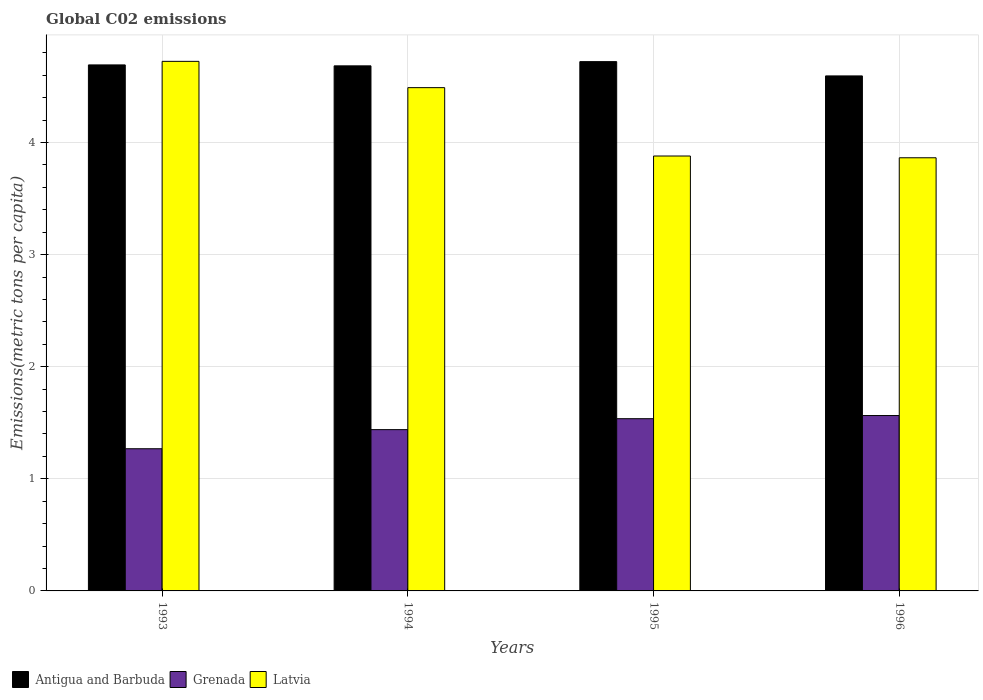How many groups of bars are there?
Your answer should be very brief. 4. Are the number of bars per tick equal to the number of legend labels?
Offer a very short reply. Yes. Are the number of bars on each tick of the X-axis equal?
Offer a terse response. Yes. What is the label of the 4th group of bars from the left?
Your answer should be very brief. 1996. In how many cases, is the number of bars for a given year not equal to the number of legend labels?
Offer a very short reply. 0. What is the amount of CO2 emitted in in Antigua and Barbuda in 1993?
Offer a very short reply. 4.69. Across all years, what is the maximum amount of CO2 emitted in in Antigua and Barbuda?
Ensure brevity in your answer.  4.72. Across all years, what is the minimum amount of CO2 emitted in in Grenada?
Ensure brevity in your answer.  1.27. What is the total amount of CO2 emitted in in Antigua and Barbuda in the graph?
Provide a short and direct response. 18.69. What is the difference between the amount of CO2 emitted in in Latvia in 1993 and that in 1994?
Offer a terse response. 0.23. What is the difference between the amount of CO2 emitted in in Antigua and Barbuda in 1993 and the amount of CO2 emitted in in Latvia in 1996?
Provide a short and direct response. 0.83. What is the average amount of CO2 emitted in in Grenada per year?
Provide a short and direct response. 1.45. In the year 1994, what is the difference between the amount of CO2 emitted in in Latvia and amount of CO2 emitted in in Antigua and Barbuda?
Keep it short and to the point. -0.19. What is the ratio of the amount of CO2 emitted in in Latvia in 1994 to that in 1995?
Offer a very short reply. 1.16. Is the difference between the amount of CO2 emitted in in Latvia in 1995 and 1996 greater than the difference between the amount of CO2 emitted in in Antigua and Barbuda in 1995 and 1996?
Your response must be concise. No. What is the difference between the highest and the second highest amount of CO2 emitted in in Antigua and Barbuda?
Offer a very short reply. 0.03. What is the difference between the highest and the lowest amount of CO2 emitted in in Latvia?
Give a very brief answer. 0.86. In how many years, is the amount of CO2 emitted in in Latvia greater than the average amount of CO2 emitted in in Latvia taken over all years?
Offer a terse response. 2. What does the 1st bar from the left in 1994 represents?
Offer a terse response. Antigua and Barbuda. What does the 3rd bar from the right in 1993 represents?
Offer a terse response. Antigua and Barbuda. How many bars are there?
Offer a terse response. 12. Are all the bars in the graph horizontal?
Offer a very short reply. No. How many years are there in the graph?
Offer a very short reply. 4. Does the graph contain any zero values?
Your answer should be compact. No. Where does the legend appear in the graph?
Provide a succinct answer. Bottom left. What is the title of the graph?
Your answer should be very brief. Global C02 emissions. What is the label or title of the Y-axis?
Your response must be concise. Emissions(metric tons per capita). What is the Emissions(metric tons per capita) of Antigua and Barbuda in 1993?
Your answer should be very brief. 4.69. What is the Emissions(metric tons per capita) of Grenada in 1993?
Your response must be concise. 1.27. What is the Emissions(metric tons per capita) of Latvia in 1993?
Make the answer very short. 4.72. What is the Emissions(metric tons per capita) in Antigua and Barbuda in 1994?
Offer a very short reply. 4.68. What is the Emissions(metric tons per capita) in Grenada in 1994?
Give a very brief answer. 1.44. What is the Emissions(metric tons per capita) in Latvia in 1994?
Provide a short and direct response. 4.49. What is the Emissions(metric tons per capita) in Antigua and Barbuda in 1995?
Keep it short and to the point. 4.72. What is the Emissions(metric tons per capita) in Grenada in 1995?
Provide a short and direct response. 1.54. What is the Emissions(metric tons per capita) of Latvia in 1995?
Your response must be concise. 3.88. What is the Emissions(metric tons per capita) of Antigua and Barbuda in 1996?
Offer a very short reply. 4.59. What is the Emissions(metric tons per capita) of Grenada in 1996?
Your answer should be very brief. 1.56. What is the Emissions(metric tons per capita) of Latvia in 1996?
Provide a succinct answer. 3.86. Across all years, what is the maximum Emissions(metric tons per capita) of Antigua and Barbuda?
Your answer should be very brief. 4.72. Across all years, what is the maximum Emissions(metric tons per capita) of Grenada?
Offer a very short reply. 1.56. Across all years, what is the maximum Emissions(metric tons per capita) in Latvia?
Offer a terse response. 4.72. Across all years, what is the minimum Emissions(metric tons per capita) in Antigua and Barbuda?
Give a very brief answer. 4.59. Across all years, what is the minimum Emissions(metric tons per capita) of Grenada?
Your answer should be compact. 1.27. Across all years, what is the minimum Emissions(metric tons per capita) of Latvia?
Make the answer very short. 3.86. What is the total Emissions(metric tons per capita) of Antigua and Barbuda in the graph?
Provide a succinct answer. 18.69. What is the total Emissions(metric tons per capita) of Grenada in the graph?
Your response must be concise. 5.81. What is the total Emissions(metric tons per capita) of Latvia in the graph?
Provide a succinct answer. 16.96. What is the difference between the Emissions(metric tons per capita) in Antigua and Barbuda in 1993 and that in 1994?
Make the answer very short. 0.01. What is the difference between the Emissions(metric tons per capita) of Grenada in 1993 and that in 1994?
Your answer should be very brief. -0.17. What is the difference between the Emissions(metric tons per capita) of Latvia in 1993 and that in 1994?
Your answer should be compact. 0.23. What is the difference between the Emissions(metric tons per capita) in Antigua and Barbuda in 1993 and that in 1995?
Your answer should be very brief. -0.03. What is the difference between the Emissions(metric tons per capita) in Grenada in 1993 and that in 1995?
Ensure brevity in your answer.  -0.27. What is the difference between the Emissions(metric tons per capita) of Latvia in 1993 and that in 1995?
Offer a very short reply. 0.84. What is the difference between the Emissions(metric tons per capita) of Antigua and Barbuda in 1993 and that in 1996?
Offer a terse response. 0.1. What is the difference between the Emissions(metric tons per capita) in Grenada in 1993 and that in 1996?
Give a very brief answer. -0.3. What is the difference between the Emissions(metric tons per capita) of Latvia in 1993 and that in 1996?
Give a very brief answer. 0.86. What is the difference between the Emissions(metric tons per capita) in Antigua and Barbuda in 1994 and that in 1995?
Ensure brevity in your answer.  -0.04. What is the difference between the Emissions(metric tons per capita) of Grenada in 1994 and that in 1995?
Provide a succinct answer. -0.1. What is the difference between the Emissions(metric tons per capita) in Latvia in 1994 and that in 1995?
Ensure brevity in your answer.  0.61. What is the difference between the Emissions(metric tons per capita) in Antigua and Barbuda in 1994 and that in 1996?
Offer a terse response. 0.09. What is the difference between the Emissions(metric tons per capita) of Grenada in 1994 and that in 1996?
Give a very brief answer. -0.13. What is the difference between the Emissions(metric tons per capita) of Latvia in 1994 and that in 1996?
Provide a succinct answer. 0.63. What is the difference between the Emissions(metric tons per capita) in Antigua and Barbuda in 1995 and that in 1996?
Your answer should be compact. 0.13. What is the difference between the Emissions(metric tons per capita) of Grenada in 1995 and that in 1996?
Offer a terse response. -0.03. What is the difference between the Emissions(metric tons per capita) of Latvia in 1995 and that in 1996?
Offer a terse response. 0.02. What is the difference between the Emissions(metric tons per capita) in Antigua and Barbuda in 1993 and the Emissions(metric tons per capita) in Grenada in 1994?
Offer a very short reply. 3.25. What is the difference between the Emissions(metric tons per capita) in Antigua and Barbuda in 1993 and the Emissions(metric tons per capita) in Latvia in 1994?
Provide a short and direct response. 0.2. What is the difference between the Emissions(metric tons per capita) of Grenada in 1993 and the Emissions(metric tons per capita) of Latvia in 1994?
Keep it short and to the point. -3.22. What is the difference between the Emissions(metric tons per capita) of Antigua and Barbuda in 1993 and the Emissions(metric tons per capita) of Grenada in 1995?
Offer a terse response. 3.16. What is the difference between the Emissions(metric tons per capita) in Antigua and Barbuda in 1993 and the Emissions(metric tons per capita) in Latvia in 1995?
Offer a very short reply. 0.81. What is the difference between the Emissions(metric tons per capita) of Grenada in 1993 and the Emissions(metric tons per capita) of Latvia in 1995?
Your response must be concise. -2.61. What is the difference between the Emissions(metric tons per capita) in Antigua and Barbuda in 1993 and the Emissions(metric tons per capita) in Grenada in 1996?
Offer a very short reply. 3.13. What is the difference between the Emissions(metric tons per capita) in Antigua and Barbuda in 1993 and the Emissions(metric tons per capita) in Latvia in 1996?
Your answer should be very brief. 0.83. What is the difference between the Emissions(metric tons per capita) of Grenada in 1993 and the Emissions(metric tons per capita) of Latvia in 1996?
Your answer should be very brief. -2.6. What is the difference between the Emissions(metric tons per capita) of Antigua and Barbuda in 1994 and the Emissions(metric tons per capita) of Grenada in 1995?
Your answer should be compact. 3.15. What is the difference between the Emissions(metric tons per capita) in Antigua and Barbuda in 1994 and the Emissions(metric tons per capita) in Latvia in 1995?
Provide a succinct answer. 0.8. What is the difference between the Emissions(metric tons per capita) of Grenada in 1994 and the Emissions(metric tons per capita) of Latvia in 1995?
Keep it short and to the point. -2.44. What is the difference between the Emissions(metric tons per capita) in Antigua and Barbuda in 1994 and the Emissions(metric tons per capita) in Grenada in 1996?
Offer a very short reply. 3.12. What is the difference between the Emissions(metric tons per capita) of Antigua and Barbuda in 1994 and the Emissions(metric tons per capita) of Latvia in 1996?
Give a very brief answer. 0.82. What is the difference between the Emissions(metric tons per capita) of Grenada in 1994 and the Emissions(metric tons per capita) of Latvia in 1996?
Your answer should be very brief. -2.42. What is the difference between the Emissions(metric tons per capita) in Antigua and Barbuda in 1995 and the Emissions(metric tons per capita) in Grenada in 1996?
Offer a terse response. 3.16. What is the difference between the Emissions(metric tons per capita) of Antigua and Barbuda in 1995 and the Emissions(metric tons per capita) of Latvia in 1996?
Your response must be concise. 0.86. What is the difference between the Emissions(metric tons per capita) of Grenada in 1995 and the Emissions(metric tons per capita) of Latvia in 1996?
Provide a succinct answer. -2.33. What is the average Emissions(metric tons per capita) in Antigua and Barbuda per year?
Your answer should be very brief. 4.67. What is the average Emissions(metric tons per capita) in Grenada per year?
Make the answer very short. 1.45. What is the average Emissions(metric tons per capita) of Latvia per year?
Give a very brief answer. 4.24. In the year 1993, what is the difference between the Emissions(metric tons per capita) in Antigua and Barbuda and Emissions(metric tons per capita) in Grenada?
Give a very brief answer. 3.42. In the year 1993, what is the difference between the Emissions(metric tons per capita) in Antigua and Barbuda and Emissions(metric tons per capita) in Latvia?
Your response must be concise. -0.03. In the year 1993, what is the difference between the Emissions(metric tons per capita) in Grenada and Emissions(metric tons per capita) in Latvia?
Ensure brevity in your answer.  -3.46. In the year 1994, what is the difference between the Emissions(metric tons per capita) in Antigua and Barbuda and Emissions(metric tons per capita) in Grenada?
Ensure brevity in your answer.  3.24. In the year 1994, what is the difference between the Emissions(metric tons per capita) in Antigua and Barbuda and Emissions(metric tons per capita) in Latvia?
Offer a terse response. 0.19. In the year 1994, what is the difference between the Emissions(metric tons per capita) of Grenada and Emissions(metric tons per capita) of Latvia?
Your response must be concise. -3.05. In the year 1995, what is the difference between the Emissions(metric tons per capita) in Antigua and Barbuda and Emissions(metric tons per capita) in Grenada?
Your answer should be very brief. 3.19. In the year 1995, what is the difference between the Emissions(metric tons per capita) in Antigua and Barbuda and Emissions(metric tons per capita) in Latvia?
Make the answer very short. 0.84. In the year 1995, what is the difference between the Emissions(metric tons per capita) in Grenada and Emissions(metric tons per capita) in Latvia?
Keep it short and to the point. -2.34. In the year 1996, what is the difference between the Emissions(metric tons per capita) in Antigua and Barbuda and Emissions(metric tons per capita) in Grenada?
Provide a succinct answer. 3.03. In the year 1996, what is the difference between the Emissions(metric tons per capita) in Antigua and Barbuda and Emissions(metric tons per capita) in Latvia?
Your answer should be very brief. 0.73. In the year 1996, what is the difference between the Emissions(metric tons per capita) of Grenada and Emissions(metric tons per capita) of Latvia?
Give a very brief answer. -2.3. What is the ratio of the Emissions(metric tons per capita) of Grenada in 1993 to that in 1994?
Make the answer very short. 0.88. What is the ratio of the Emissions(metric tons per capita) of Latvia in 1993 to that in 1994?
Your answer should be compact. 1.05. What is the ratio of the Emissions(metric tons per capita) of Antigua and Barbuda in 1993 to that in 1995?
Provide a succinct answer. 0.99. What is the ratio of the Emissions(metric tons per capita) of Grenada in 1993 to that in 1995?
Provide a succinct answer. 0.83. What is the ratio of the Emissions(metric tons per capita) in Latvia in 1993 to that in 1995?
Your answer should be very brief. 1.22. What is the ratio of the Emissions(metric tons per capita) of Antigua and Barbuda in 1993 to that in 1996?
Your answer should be very brief. 1.02. What is the ratio of the Emissions(metric tons per capita) in Grenada in 1993 to that in 1996?
Make the answer very short. 0.81. What is the ratio of the Emissions(metric tons per capita) of Latvia in 1993 to that in 1996?
Keep it short and to the point. 1.22. What is the ratio of the Emissions(metric tons per capita) of Grenada in 1994 to that in 1995?
Offer a terse response. 0.94. What is the ratio of the Emissions(metric tons per capita) in Latvia in 1994 to that in 1995?
Keep it short and to the point. 1.16. What is the ratio of the Emissions(metric tons per capita) of Antigua and Barbuda in 1994 to that in 1996?
Offer a terse response. 1.02. What is the ratio of the Emissions(metric tons per capita) in Grenada in 1994 to that in 1996?
Your answer should be compact. 0.92. What is the ratio of the Emissions(metric tons per capita) in Latvia in 1994 to that in 1996?
Give a very brief answer. 1.16. What is the ratio of the Emissions(metric tons per capita) in Antigua and Barbuda in 1995 to that in 1996?
Offer a terse response. 1.03. What is the difference between the highest and the second highest Emissions(metric tons per capita) in Antigua and Barbuda?
Offer a very short reply. 0.03. What is the difference between the highest and the second highest Emissions(metric tons per capita) in Grenada?
Your response must be concise. 0.03. What is the difference between the highest and the second highest Emissions(metric tons per capita) of Latvia?
Your answer should be very brief. 0.23. What is the difference between the highest and the lowest Emissions(metric tons per capita) of Antigua and Barbuda?
Keep it short and to the point. 0.13. What is the difference between the highest and the lowest Emissions(metric tons per capita) in Grenada?
Offer a terse response. 0.3. What is the difference between the highest and the lowest Emissions(metric tons per capita) of Latvia?
Make the answer very short. 0.86. 